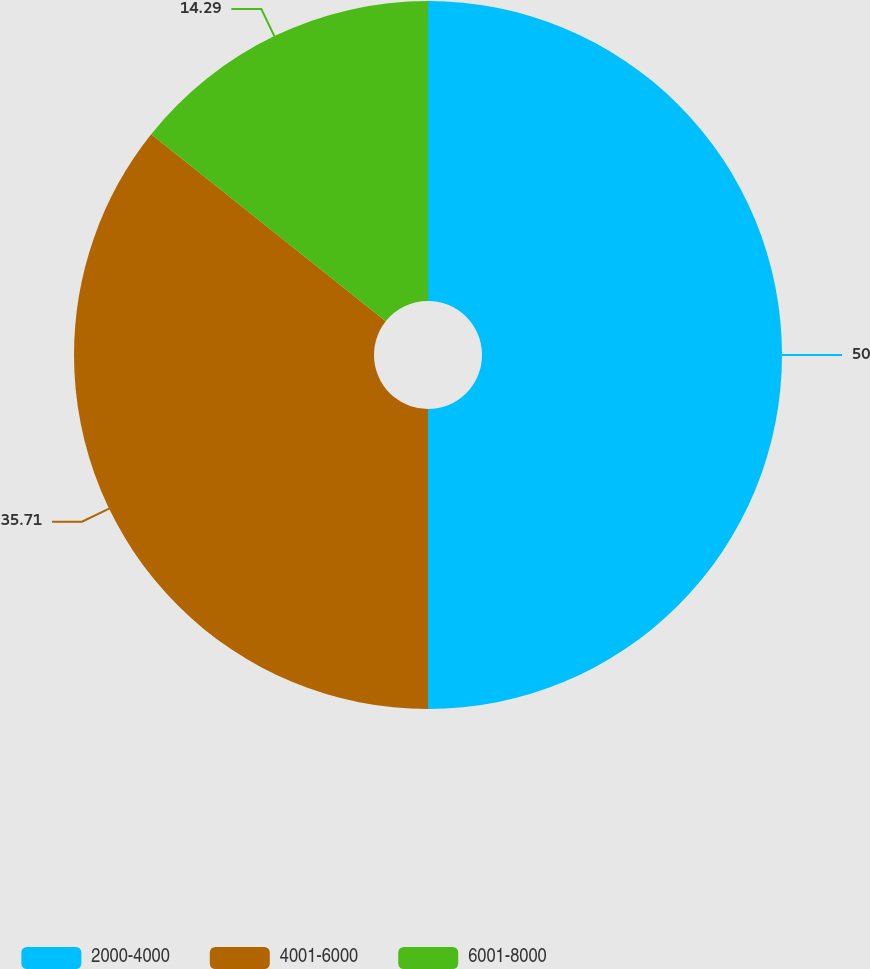<chart> <loc_0><loc_0><loc_500><loc_500><pie_chart><fcel>2000-4000<fcel>4001-6000<fcel>6001-8000<nl><fcel>50.0%<fcel>35.71%<fcel>14.29%<nl></chart> 